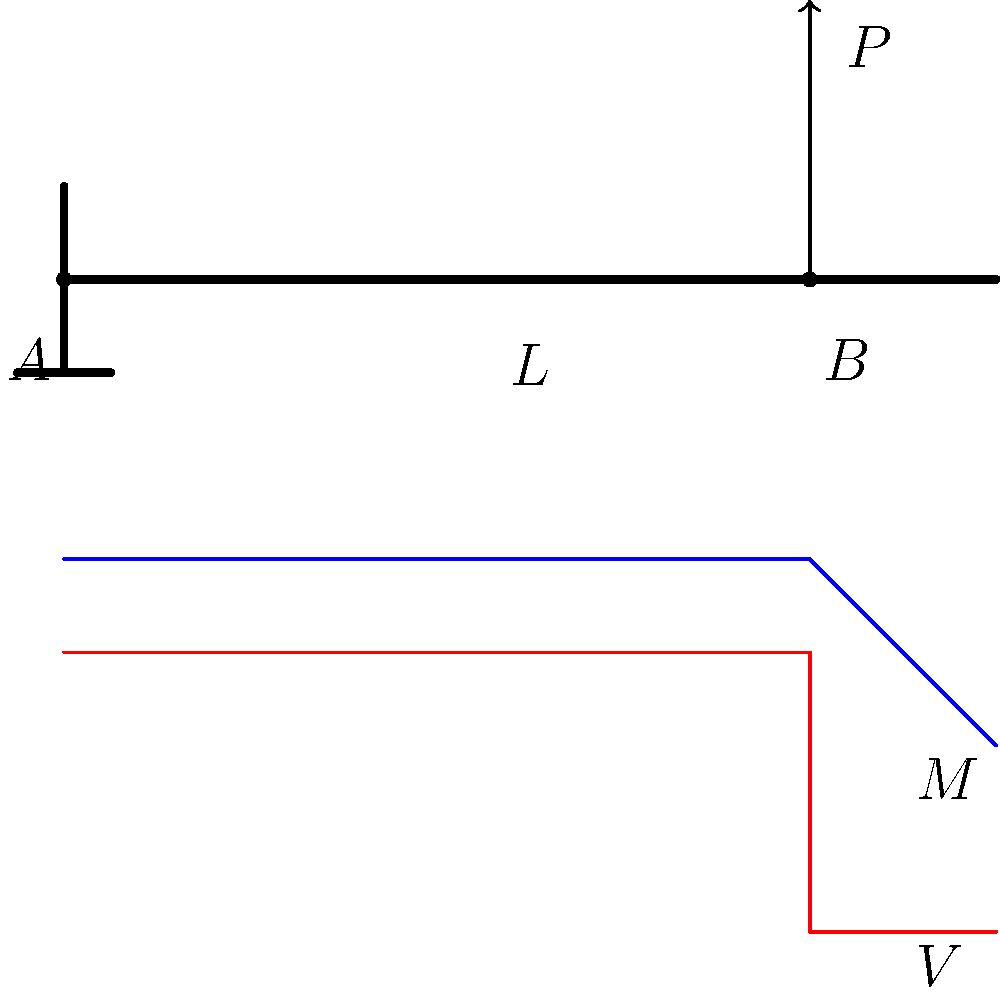In the cantilever beam shown above, a point load $P$ is applied at a distance of $0.8L$ from the fixed end, where $L$ is the total length of the beam. If the maximum bending stress in the beam is $\sigma_{max} = \frac{Mc}{I}$, where $M$ is the bending moment, $c$ is the distance from the neutral axis to the outermost fiber, and $I$ is the moment of inertia, at which point along the beam does this maximum stress occur? To determine the location of maximum bending stress, we need to analyze the bending moment distribution along the beam:

1. The maximum bending moment occurs at the fixed end (point A) because:
   a) The bending moment increases linearly from the free end to the fixed end.
   b) The bending moment at any point is given by $M = P \cdot x$, where $x$ is the distance from the load to that point.

2. At the fixed end (point A):
   $M_{max} = P \cdot 0.8L$

3. At the point of load application (point B):
   $M_B = 0$ (no moment to the right of the applied load)

4. The bending stress equation is $\sigma = \frac{Mc}{I}$
   Where $c$ and $I$ are constant for a given beam cross-section.

5. Since $c$ and $I$ are constant, the maximum stress will occur where $M$ is maximum.

6. The maximum moment occurs at the fixed end (point A), so the maximum bending stress also occurs at point A.

Therefore, the maximum bending stress occurs at the fixed end of the cantilever beam (point A).
Answer: At the fixed end (point A) 